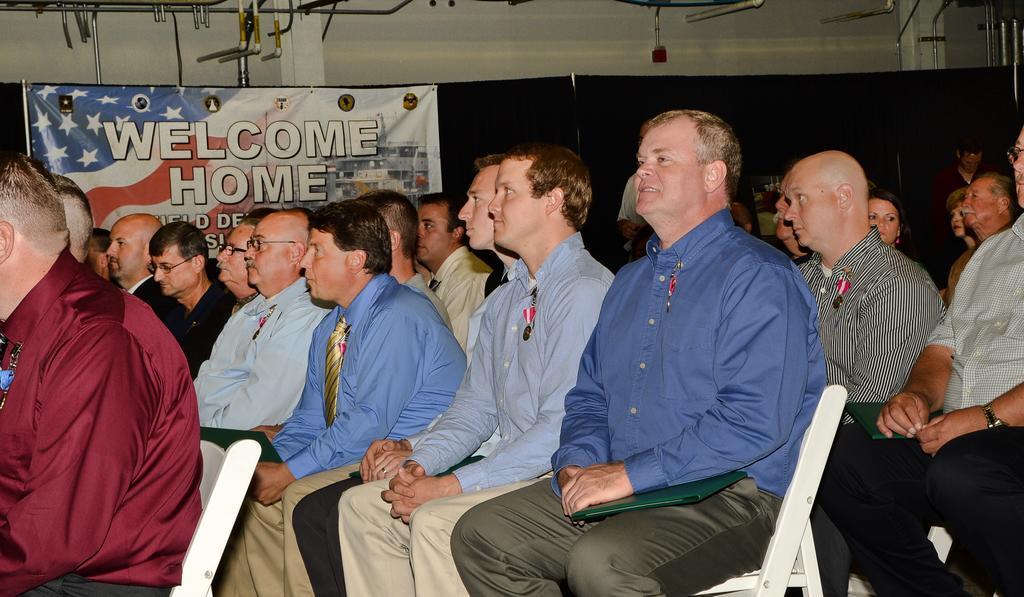Could you give a brief overview of what you see in this image? Here a man is sitting on the white color chair, he wore a blue color shirt. Few other men are also sitting on the chairs. In the left side it is a banner. 